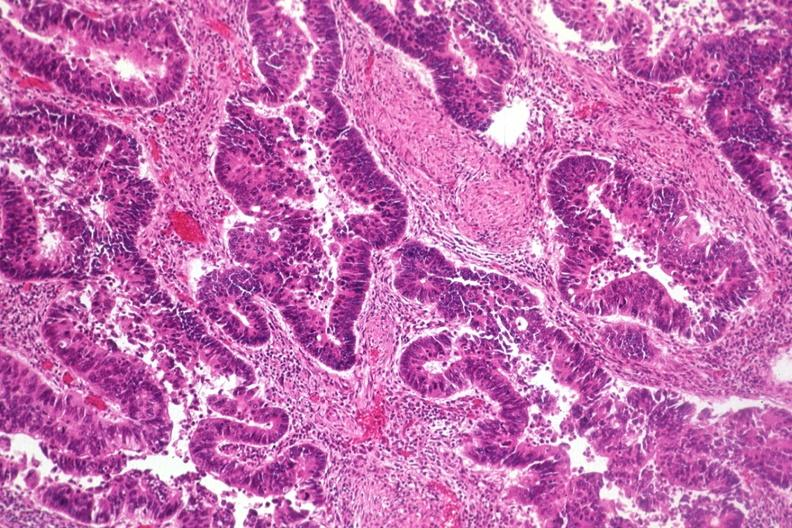what is present?
Answer the question using a single word or phrase. Colon 